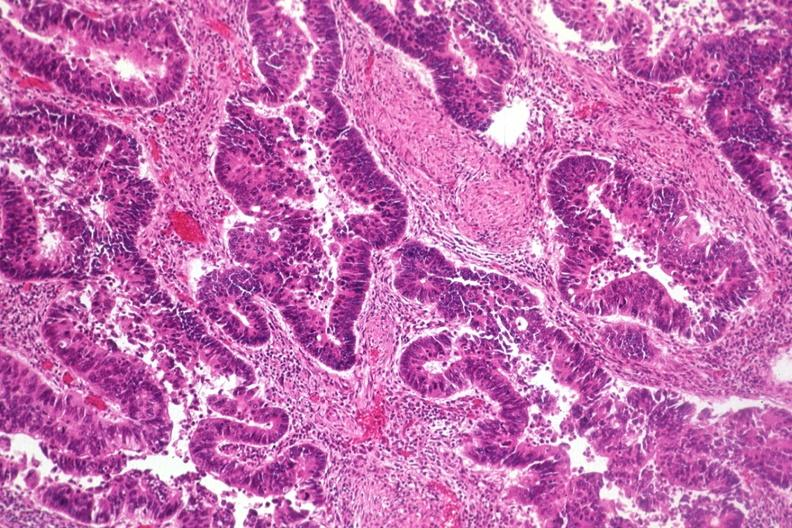what is present?
Answer the question using a single word or phrase. Colon 